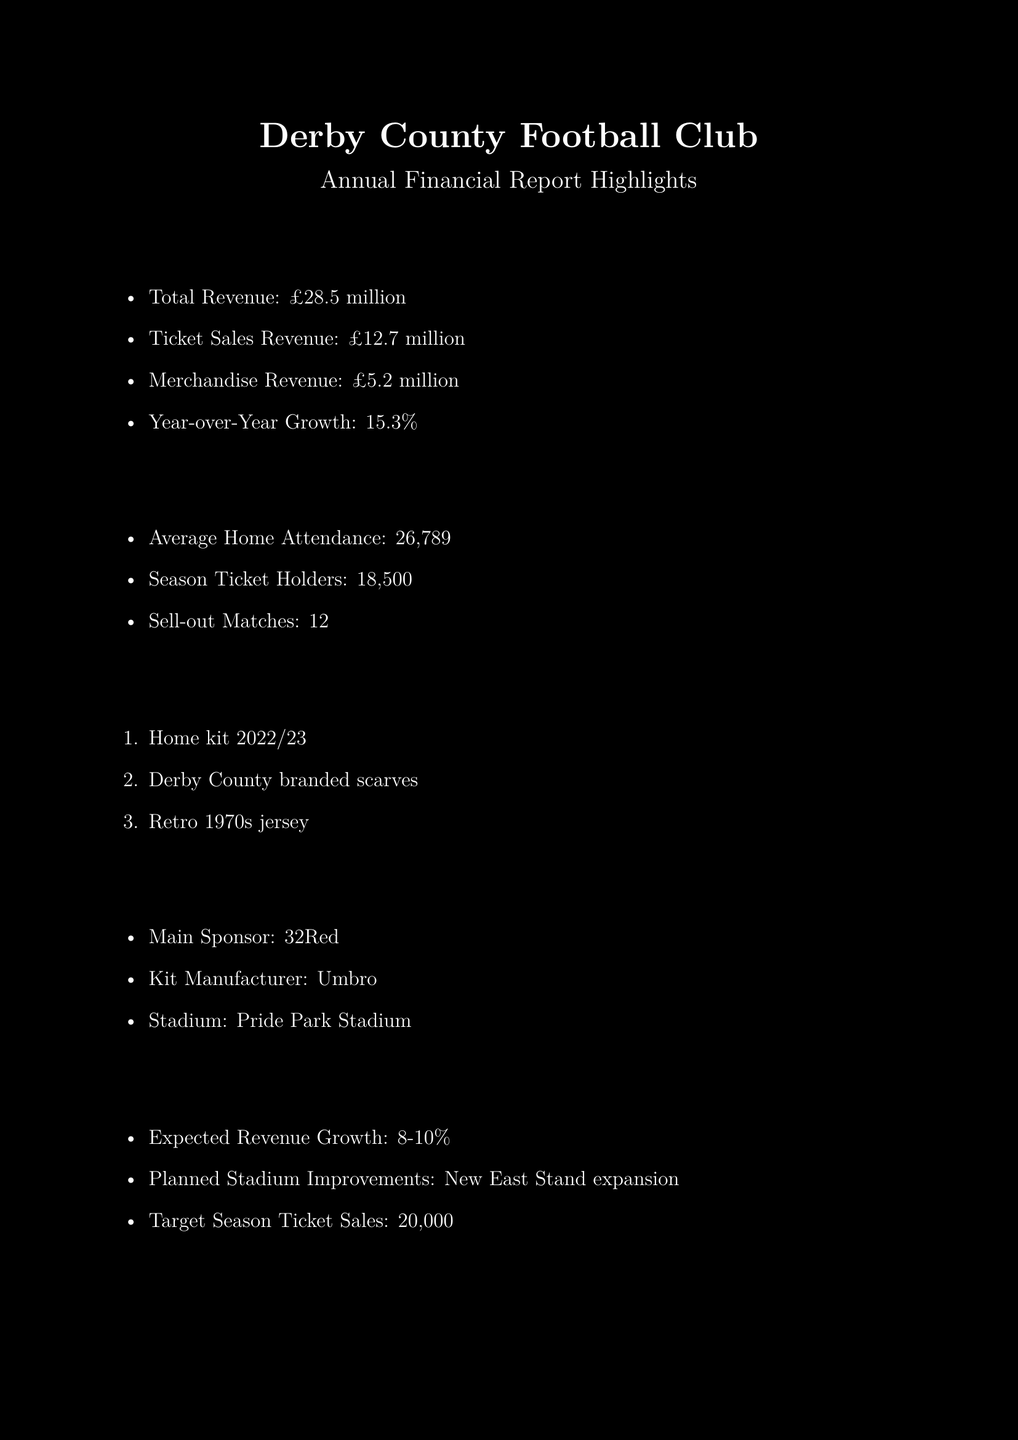what is the total revenue? The total revenue is the aggregate sum of all revenue streams listed in the highlights of the financial report.
Answer: £28.5 million how much revenue did ticket sales generate? The ticket sales revenue is highlighted separately and indicates the amount earned from ticket sales.
Answer: £12.7 million what is the merchandise revenue? Merchandise revenue is provided as a specific amount that the club earned from merchandise sales during the fiscal year.
Answer: £5.2 million how much did the average home attendance amount to? The average home attendance gives an insight into the fan engagement and support during home matches.
Answer: 26,789 how many sell-out matches did the club have? The number of sell-out matches indicates the popularity and demand for games, reflecting fan engagement.
Answer: 12 what is the year-over-year growth percentage? The year-over-year growth percentage reflects the financial performance compared to the previous year.
Answer: 15.3% what is the target for season ticket sales? The target for season ticket sales showcases the club's ambition in terms of fan engagement and revenue generation for the future.
Answer: 20,000 what are the three merchandise bestsellers? These items highlight popular merchandise, indicating what fans are most interested in purchasing.
Answer: Home kit 2022/23, Derby County branded scarves, Retro 1970s jersey what is planned for stadium improvements? This information indicates the club’s future plans for enhancing their facilities, which may attract more fans and increase revenue.
Answer: New East Stand expansion 